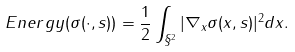Convert formula to latex. <formula><loc_0><loc_0><loc_500><loc_500>E n e r g y ( \sigma ( \cdot , s ) ) = \frac { 1 } { 2 } \int _ { \S ^ { 2 } } | \nabla _ { x } \sigma ( x , s ) | ^ { 2 } d x .</formula> 